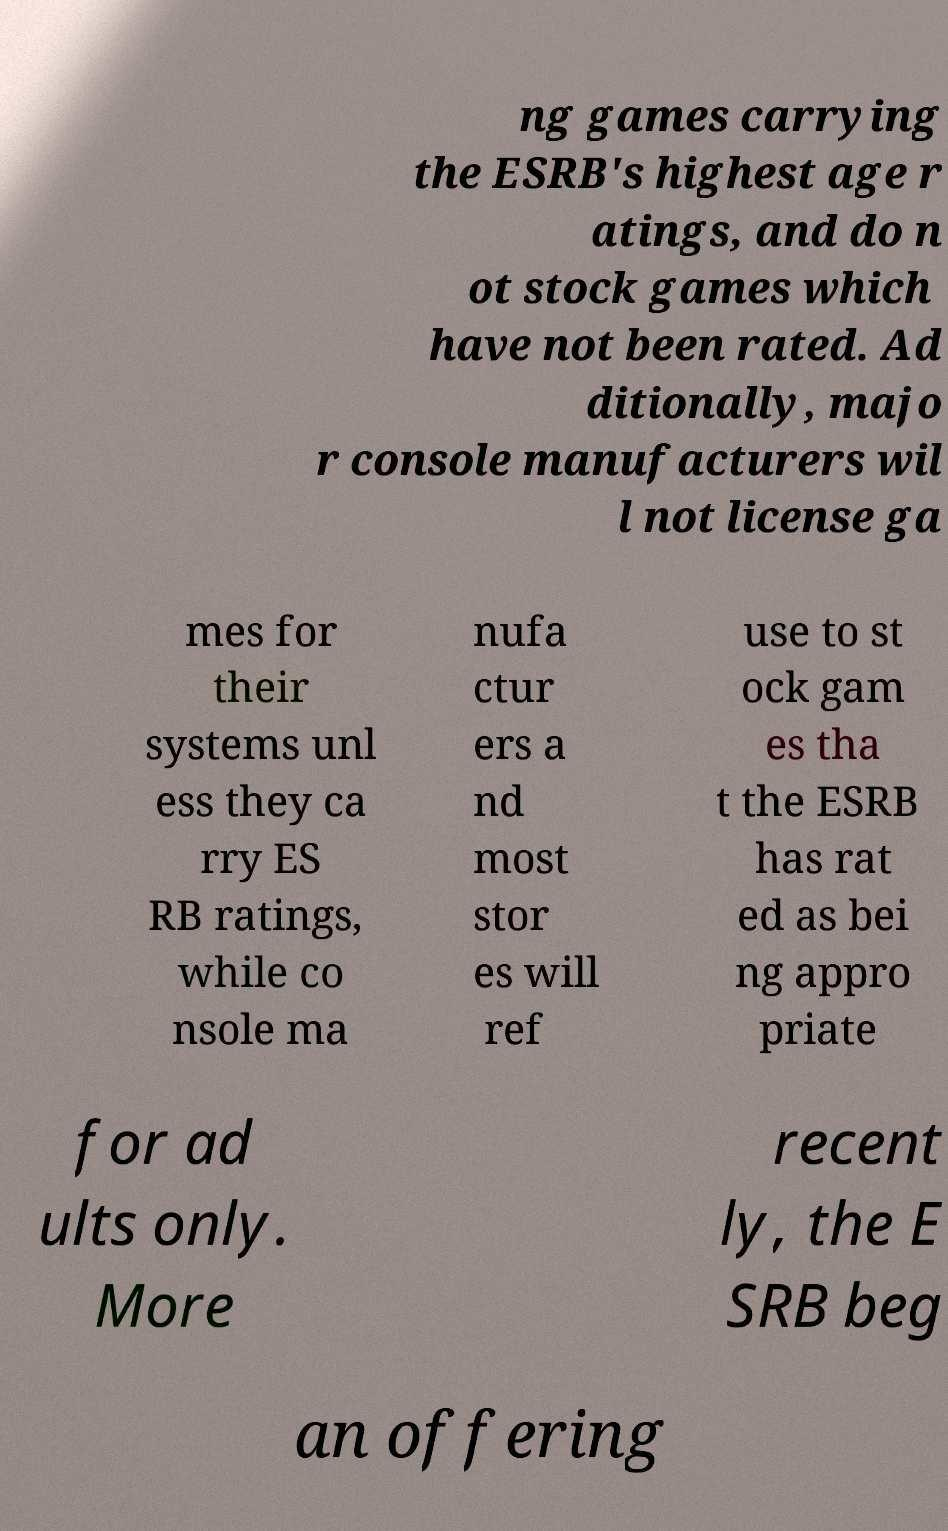I need the written content from this picture converted into text. Can you do that? ng games carrying the ESRB's highest age r atings, and do n ot stock games which have not been rated. Ad ditionally, majo r console manufacturers wil l not license ga mes for their systems unl ess they ca rry ES RB ratings, while co nsole ma nufa ctur ers a nd most stor es will ref use to st ock gam es tha t the ESRB has rat ed as bei ng appro priate for ad ults only. More recent ly, the E SRB beg an offering 